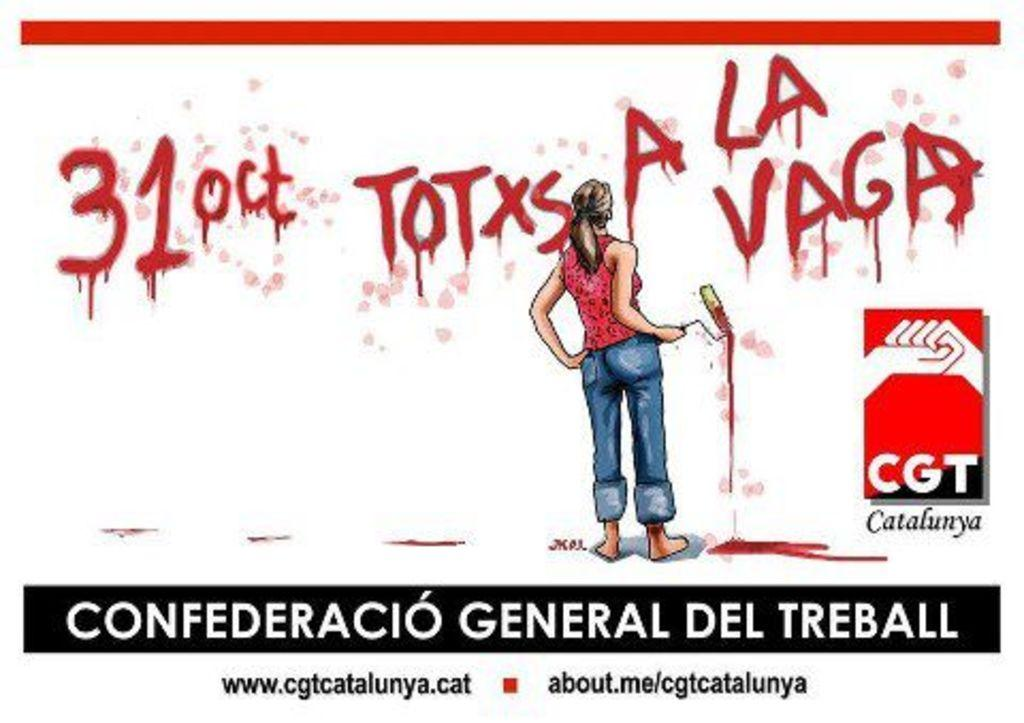What is featured on the poster in the image? The poster contains a woman. What is the woman holding in the image? The woman is holding a paint roller. Where is the woman standing in the image? The woman is standing on the floor. What is behind the woman in the image? The woman is in front of a wall. What can be seen on the wall in the image? There are texts on the wall. Are there any additional texts in the image? Yes, there are additional texts below the wall. Can you see a yak on the roof in the image? There is no roof or yak present in the image. How many toads are visible on the wall in the image? There are no toads visible on the wall in the image. 